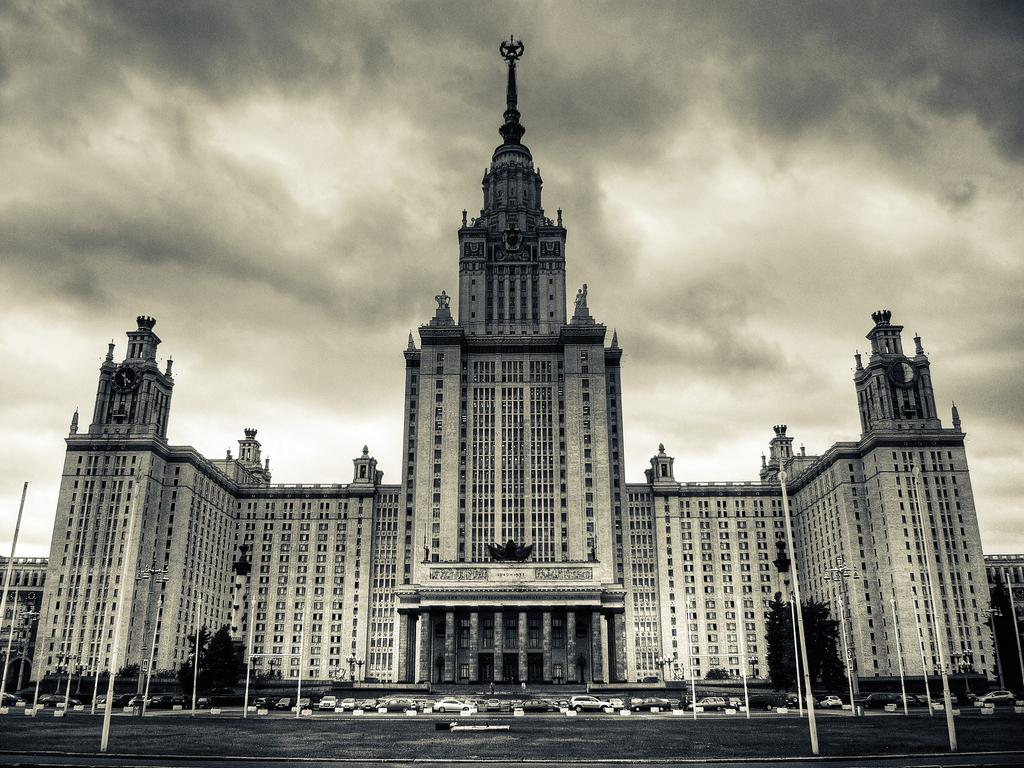What type of structure is present in the image? There is a building in the image. What can be seen in front of the building? There are vehicles in front of the building. What type of vegetation is visible in the image? There are trees visible in the image. How would you describe the sky in the image? The sky is clouded in the image. What type of learning material can be seen on the trees in the image? There are no learning materials present on the trees in the image; only trees are visible. 